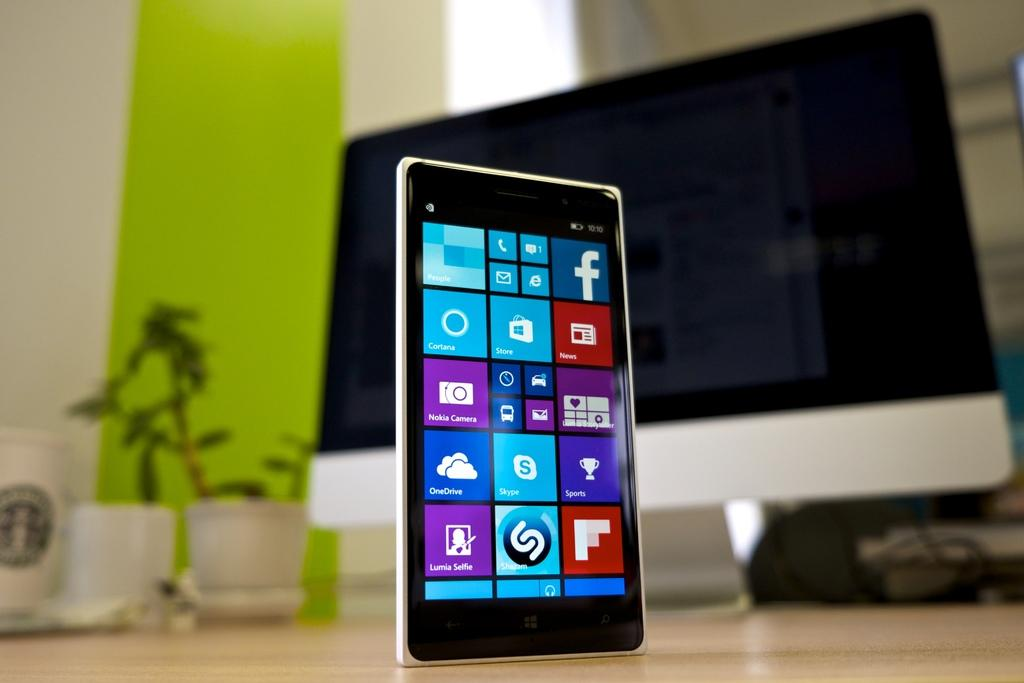Provide a one-sentence caption for the provided image. An app screen on a phone showing programs like Skype and Facebook. 